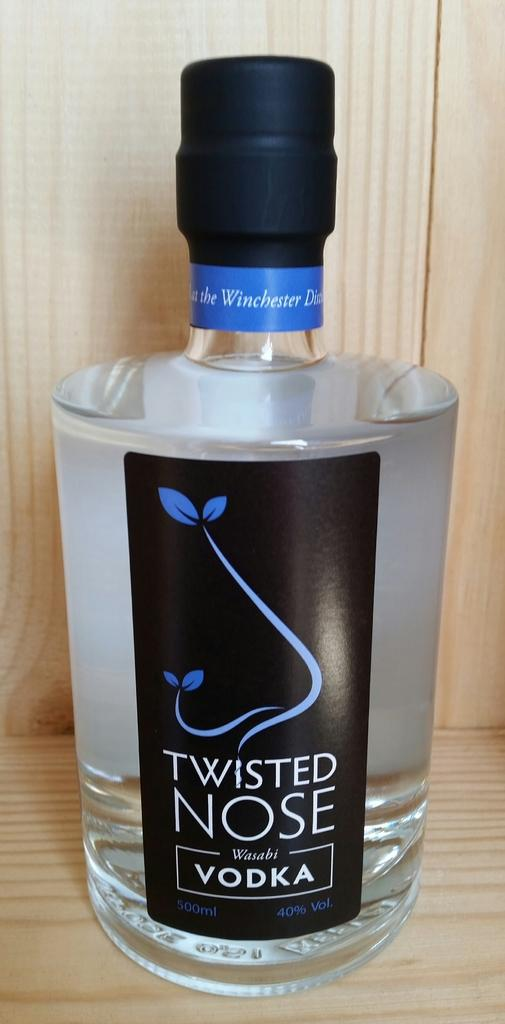Provide a one-sentence caption for the provided image. On the counter sits a full, large bottle of Twisted Nose vodka. 